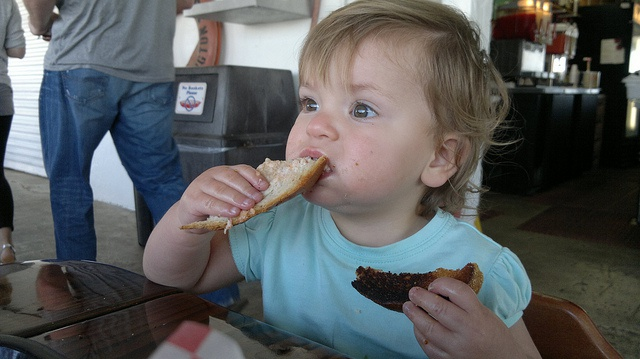Describe the objects in this image and their specific colors. I can see people in gray and darkgray tones, people in gray, navy, blue, and black tones, dining table in gray and black tones, pizza in gray, darkgray, and maroon tones, and pizza in gray, black, and maroon tones in this image. 